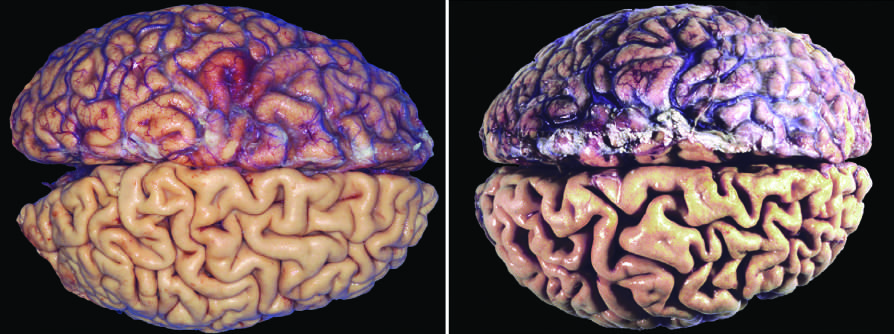s atrophy seen in the brain?
Answer the question using a single word or phrase. Yes 